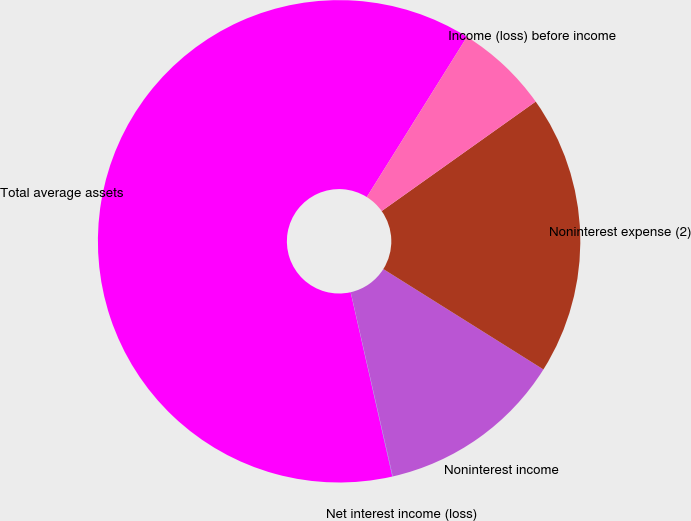<chart> <loc_0><loc_0><loc_500><loc_500><pie_chart><fcel>Total average assets<fcel>Net interest income (loss)<fcel>Noninterest income<fcel>Noninterest expense (2)<fcel>Income (loss) before income<nl><fcel>62.44%<fcel>0.03%<fcel>12.51%<fcel>18.75%<fcel>6.27%<nl></chart> 